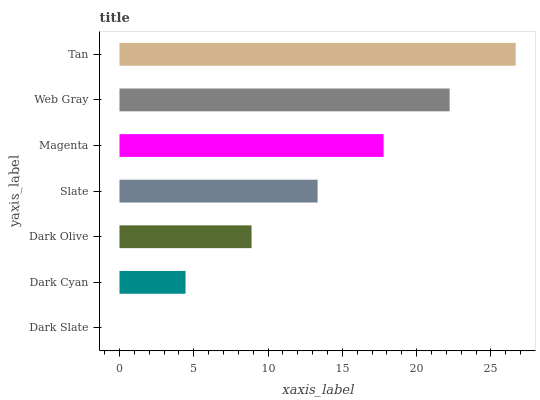Is Dark Slate the minimum?
Answer yes or no. Yes. Is Tan the maximum?
Answer yes or no. Yes. Is Dark Cyan the minimum?
Answer yes or no. No. Is Dark Cyan the maximum?
Answer yes or no. No. Is Dark Cyan greater than Dark Slate?
Answer yes or no. Yes. Is Dark Slate less than Dark Cyan?
Answer yes or no. Yes. Is Dark Slate greater than Dark Cyan?
Answer yes or no. No. Is Dark Cyan less than Dark Slate?
Answer yes or no. No. Is Slate the high median?
Answer yes or no. Yes. Is Slate the low median?
Answer yes or no. Yes. Is Web Gray the high median?
Answer yes or no. No. Is Dark Slate the low median?
Answer yes or no. No. 